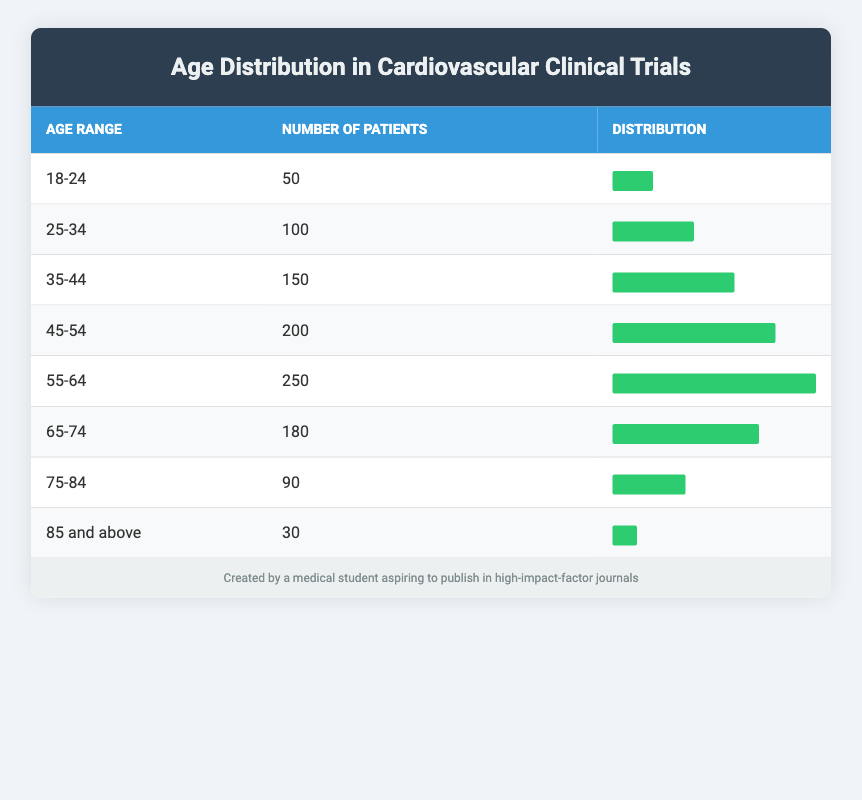What is the age range with the highest number of patients? By reviewing the table, the age range 55-64 corresponds to the highest number of patients, which is 250. This can be found directly by comparing the "number of patients" column across all age ranges.
Answer: 55-64 How many patients are there in the age range 35-44? Looking at the table, the age range 35-44 has a total of 150 patients listed under "number of patients."
Answer: 150 What is the total number of patients aged 65 and older? To find this, we add the number of patients in the ranges 65-74, 75-84, and 85 and above. This is calculated as 180 (65-74) + 90 (75-84) + 30 (85 and above) = 300.
Answer: 300 Is it true that there are more patients aged 45-54 than patients aged 25-34? By comparing the numbers directly from the table, we see that 200 patients are aged 45-54 while only 100 patients are aged 25-34, making the statement true.
Answer: Yes What percentage of the total patients are in the age range 55-64? First, we calculate the total number of patients across all age ranges: 50 + 100 + 150 + 200 + 250 + 180 + 90 + 30 = 1,050. Next, we find the percentage for the 55-64 age range, which has 250 patients: (250/1050) * 100 = 23.81%. This means approximately 23.81% of patients fall into this age group.
Answer: 23.81% How does the number of patients aged 75-84 compare to those aged 18-24? According to the table, the number of patients aged 75-84 is 90, while the 18-24 age range has 50 patients. Thus, we can conclude that there are more patients in the 75-84 age range as 90 is greater than 50.
Answer: There are more patients aged 75-84 How many patients are there aged 18-34 combined? This number is acquired by adding patients in the age ranges 18-24 and 25-34, which are 50 and 100 respectively. Therefore, the calculation is 50 + 100 = 150.
Answer: 150 Which age group has the lowest number of participants in the clinical trials? Upon examining the numbers across all age ranges in the table, the age group 85 and above has the lowest number of participants at 30. Therefore, this age range has the least representation in the trials.
Answer: 85 and above 